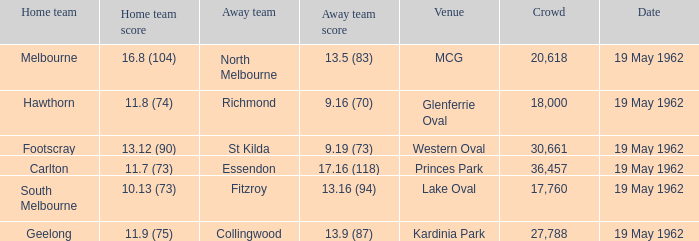What is the home side's score at mcg? 16.8 (104). Give me the full table as a dictionary. {'header': ['Home team', 'Home team score', 'Away team', 'Away team score', 'Venue', 'Crowd', 'Date'], 'rows': [['Melbourne', '16.8 (104)', 'North Melbourne', '13.5 (83)', 'MCG', '20,618', '19 May 1962'], ['Hawthorn', '11.8 (74)', 'Richmond', '9.16 (70)', 'Glenferrie Oval', '18,000', '19 May 1962'], ['Footscray', '13.12 (90)', 'St Kilda', '9.19 (73)', 'Western Oval', '30,661', '19 May 1962'], ['Carlton', '11.7 (73)', 'Essendon', '17.16 (118)', 'Princes Park', '36,457', '19 May 1962'], ['South Melbourne', '10.13 (73)', 'Fitzroy', '13.16 (94)', 'Lake Oval', '17,760', '19 May 1962'], ['Geelong', '11.9 (75)', 'Collingwood', '13.9 (87)', 'Kardinia Park', '27,788', '19 May 1962']]} 